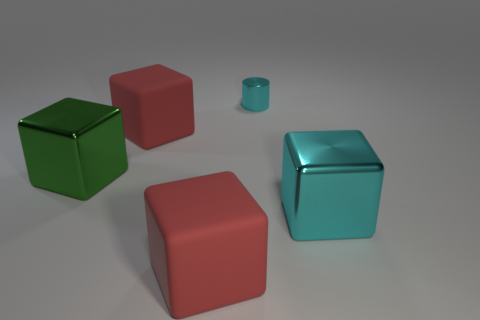Can you tell me something about the lighting in this scene? The lighting in this scene is soft and diffuse, suggesting an indoor setup with ambient light. There's a subtle cast shadow under each object, indicating a light source positioned above the objects, likely intending to create a neutral environment to focus attention on the objects themselves. 